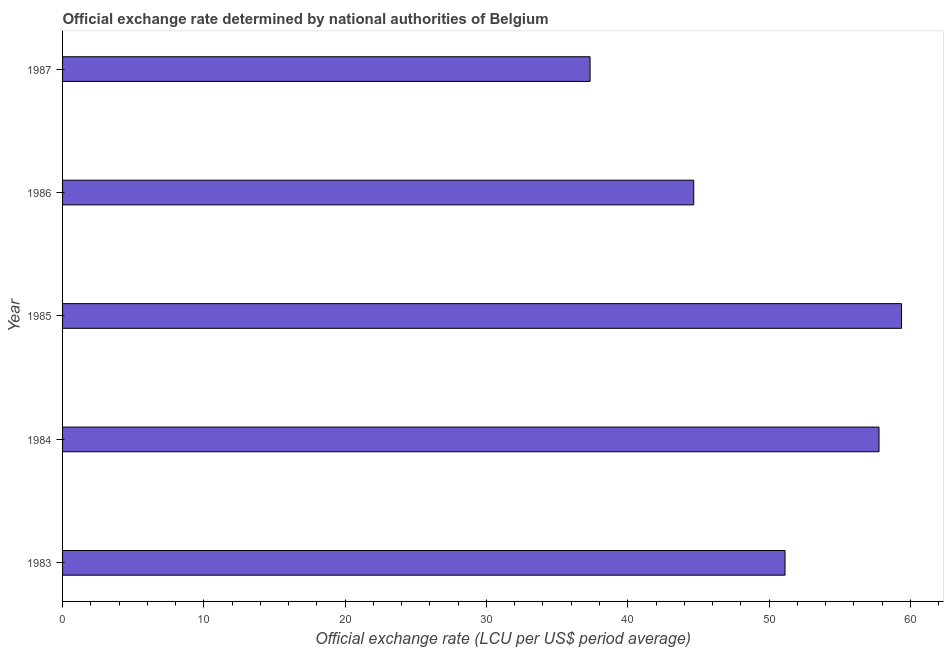Does the graph contain grids?
Your response must be concise. No. What is the title of the graph?
Provide a succinct answer. Official exchange rate determined by national authorities of Belgium. What is the label or title of the X-axis?
Offer a terse response. Official exchange rate (LCU per US$ period average). What is the official exchange rate in 1983?
Ensure brevity in your answer.  51.13. Across all years, what is the maximum official exchange rate?
Offer a very short reply. 59.38. Across all years, what is the minimum official exchange rate?
Make the answer very short. 37.33. In which year was the official exchange rate minimum?
Offer a terse response. 1987. What is the sum of the official exchange rate?
Make the answer very short. 250.3. What is the difference between the official exchange rate in 1984 and 1987?
Offer a very short reply. 20.45. What is the average official exchange rate per year?
Give a very brief answer. 50.06. What is the median official exchange rate?
Ensure brevity in your answer.  51.13. In how many years, is the official exchange rate greater than 22 ?
Offer a very short reply. 5. What is the ratio of the official exchange rate in 1983 to that in 1986?
Offer a very short reply. 1.15. What is the difference between the highest and the second highest official exchange rate?
Your answer should be compact. 1.59. Is the sum of the official exchange rate in 1983 and 1984 greater than the maximum official exchange rate across all years?
Ensure brevity in your answer.  Yes. What is the difference between the highest and the lowest official exchange rate?
Your answer should be compact. 22.04. What is the difference between two consecutive major ticks on the X-axis?
Your answer should be compact. 10. What is the Official exchange rate (LCU per US$ period average) in 1983?
Offer a terse response. 51.13. What is the Official exchange rate (LCU per US$ period average) of 1984?
Make the answer very short. 57.78. What is the Official exchange rate (LCU per US$ period average) of 1985?
Your response must be concise. 59.38. What is the Official exchange rate (LCU per US$ period average) of 1986?
Your answer should be compact. 44.67. What is the Official exchange rate (LCU per US$ period average) of 1987?
Your answer should be compact. 37.33. What is the difference between the Official exchange rate (LCU per US$ period average) in 1983 and 1984?
Provide a short and direct response. -6.65. What is the difference between the Official exchange rate (LCU per US$ period average) in 1983 and 1985?
Provide a short and direct response. -8.25. What is the difference between the Official exchange rate (LCU per US$ period average) in 1983 and 1986?
Keep it short and to the point. 6.46. What is the difference between the Official exchange rate (LCU per US$ period average) in 1983 and 1987?
Make the answer very short. 13.8. What is the difference between the Official exchange rate (LCU per US$ period average) in 1984 and 1985?
Your answer should be compact. -1.59. What is the difference between the Official exchange rate (LCU per US$ period average) in 1984 and 1986?
Provide a short and direct response. 13.11. What is the difference between the Official exchange rate (LCU per US$ period average) in 1984 and 1987?
Offer a very short reply. 20.45. What is the difference between the Official exchange rate (LCU per US$ period average) in 1985 and 1986?
Offer a terse response. 14.71. What is the difference between the Official exchange rate (LCU per US$ period average) in 1985 and 1987?
Ensure brevity in your answer.  22.04. What is the difference between the Official exchange rate (LCU per US$ period average) in 1986 and 1987?
Offer a very short reply. 7.34. What is the ratio of the Official exchange rate (LCU per US$ period average) in 1983 to that in 1984?
Your response must be concise. 0.89. What is the ratio of the Official exchange rate (LCU per US$ period average) in 1983 to that in 1985?
Offer a terse response. 0.86. What is the ratio of the Official exchange rate (LCU per US$ period average) in 1983 to that in 1986?
Keep it short and to the point. 1.15. What is the ratio of the Official exchange rate (LCU per US$ period average) in 1983 to that in 1987?
Keep it short and to the point. 1.37. What is the ratio of the Official exchange rate (LCU per US$ period average) in 1984 to that in 1986?
Your response must be concise. 1.29. What is the ratio of the Official exchange rate (LCU per US$ period average) in 1984 to that in 1987?
Make the answer very short. 1.55. What is the ratio of the Official exchange rate (LCU per US$ period average) in 1985 to that in 1986?
Your response must be concise. 1.33. What is the ratio of the Official exchange rate (LCU per US$ period average) in 1985 to that in 1987?
Provide a succinct answer. 1.59. What is the ratio of the Official exchange rate (LCU per US$ period average) in 1986 to that in 1987?
Provide a succinct answer. 1.2. 